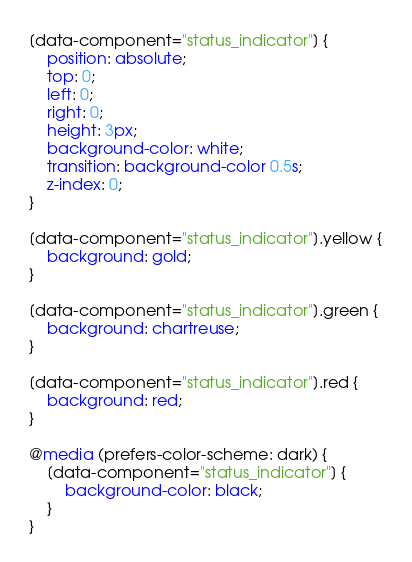Convert code to text. <code><loc_0><loc_0><loc_500><loc_500><_CSS_>[data-component="status_indicator"] {
    position: absolute;
    top: 0;
    left: 0;
    right: 0;
    height: 3px;
    background-color: white;
    transition: background-color 0.5s;
    z-index: 0;
}

[data-component="status_indicator"].yellow {
    background: gold;
}

[data-component="status_indicator"].green {
    background: chartreuse;
}

[data-component="status_indicator"].red {
    background: red;
}

@media (prefers-color-scheme: dark) {
    [data-component="status_indicator"] {
        background-color: black;
    }
}</code> 